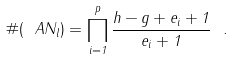Convert formula to latex. <formula><loc_0><loc_0><loc_500><loc_500>\# ( \ A N _ { l } ) = \prod _ { i = 1 } ^ { p } \frac { h - g + e _ { i } + 1 } { e _ { i } + 1 } \ .</formula> 